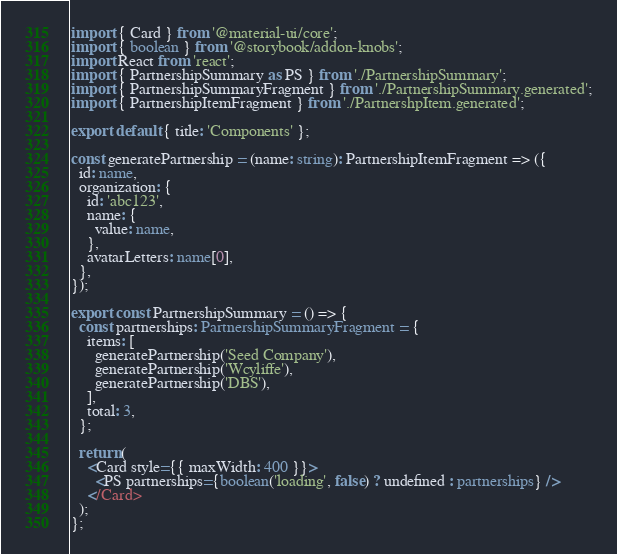<code> <loc_0><loc_0><loc_500><loc_500><_TypeScript_>import { Card } from '@material-ui/core';
import { boolean } from '@storybook/addon-knobs';
import React from 'react';
import { PartnershipSummary as PS } from './PartnershipSummary';
import { PartnershipSummaryFragment } from './PartnershipSummary.generated';
import { PartnershipItemFragment } from './PartnershpItem.generated';

export default { title: 'Components' };

const generatePartnership = (name: string): PartnershipItemFragment => ({
  id: name,
  organization: {
    id: 'abc123',
    name: {
      value: name,
    },
    avatarLetters: name[0],
  },
});

export const PartnershipSummary = () => {
  const partnerships: PartnershipSummaryFragment = {
    items: [
      generatePartnership('Seed Company'),
      generatePartnership('Wcyliffe'),
      generatePartnership('DBS'),
    ],
    total: 3,
  };

  return (
    <Card style={{ maxWidth: 400 }}>
      <PS partnerships={boolean('loading', false) ? undefined : partnerships} />
    </Card>
  );
};
</code> 